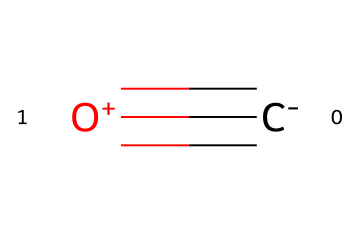What is the molecular formula of this compound? The SMILES representation shows one carbon atom (C) connected to one oxygen atom (O) with a triple bond. Therefore, the molecular formula is derived from the count of these atoms.
Answer: CO How many total atoms are in this molecule? The structure contains one carbon atom and one oxygen atom. By adding these together, we find the total number of atoms is two.
Answer: 2 What type of bond exists between the carbon and oxygen in this molecule? The SMILES notation specifies a triple bond between the carbon atom and the oxygen atom, which indicates that three pairs of electrons are shared.
Answer: Triple bond Is carbon monoxide a flammable gas? Carbon monoxide can ignite and combust under proper conditions, making it a flammable gas.
Answer: Yes Why is carbon monoxide considered hazardous? The molecule's ability to bind with hemoglobin in blood is significantly stronger than that of oxygen, preventing oxygen transport and leading to tissue hypoxia.
Answer: Tissue hypoxia What is the typical source of carbon monoxide emissions? Vehicle exhaust is a primary source of carbon monoxide emissions, particularly from the incomplete combustion of fossil fuels in engines.
Answer: Vehicle exhaust What effect does carbon monoxide have on human health? Carbon monoxide exposure can result in symptoms like headaches and dizziness, and it can be fatal in high concentrations due to its effects on the respiratory system and blood oxygen levels.
Answer: Fatal 